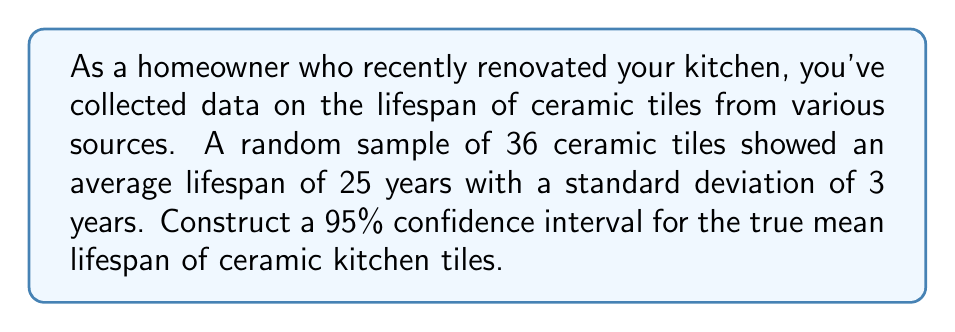Can you answer this question? To construct a 95% confidence interval for the true mean lifespan of ceramic kitchen tiles, we'll follow these steps:

1. Identify the given information:
   - Sample size: $n = 36$
   - Sample mean: $\bar{x} = 25$ years
   - Sample standard deviation: $s = 3$ years
   - Confidence level: 95% (α = 0.05)

2. Determine the critical value:
   For a 95% confidence interval with 35 degrees of freedom (n - 1), we use the t-distribution. The critical value is $t_{0.025, 35} = 2.030$.

3. Calculate the margin of error:
   Margin of error = $t_{0.025, 35} \cdot \frac{s}{\sqrt{n}}$
   $$ \text{Margin of error} = 2.030 \cdot \frac{3}{\sqrt{36}} = 2.030 \cdot 0.5 = 1.015 $$

4. Construct the confidence interval:
   The formula for the confidence interval is:
   $$ \text{CI} = \bar{x} \pm \text{Margin of error} $$
   $$ \text{CI} = 25 \pm 1.015 $$
   $$ \text{CI} = (23.985, 26.015) $$

5. Round the results to two decimal places:
   $$ \text{CI} = (23.99, 26.01) $$

Therefore, we can be 95% confident that the true mean lifespan of ceramic kitchen tiles falls between 23.99 and 26.01 years.
Answer: (23.99, 26.01) years 